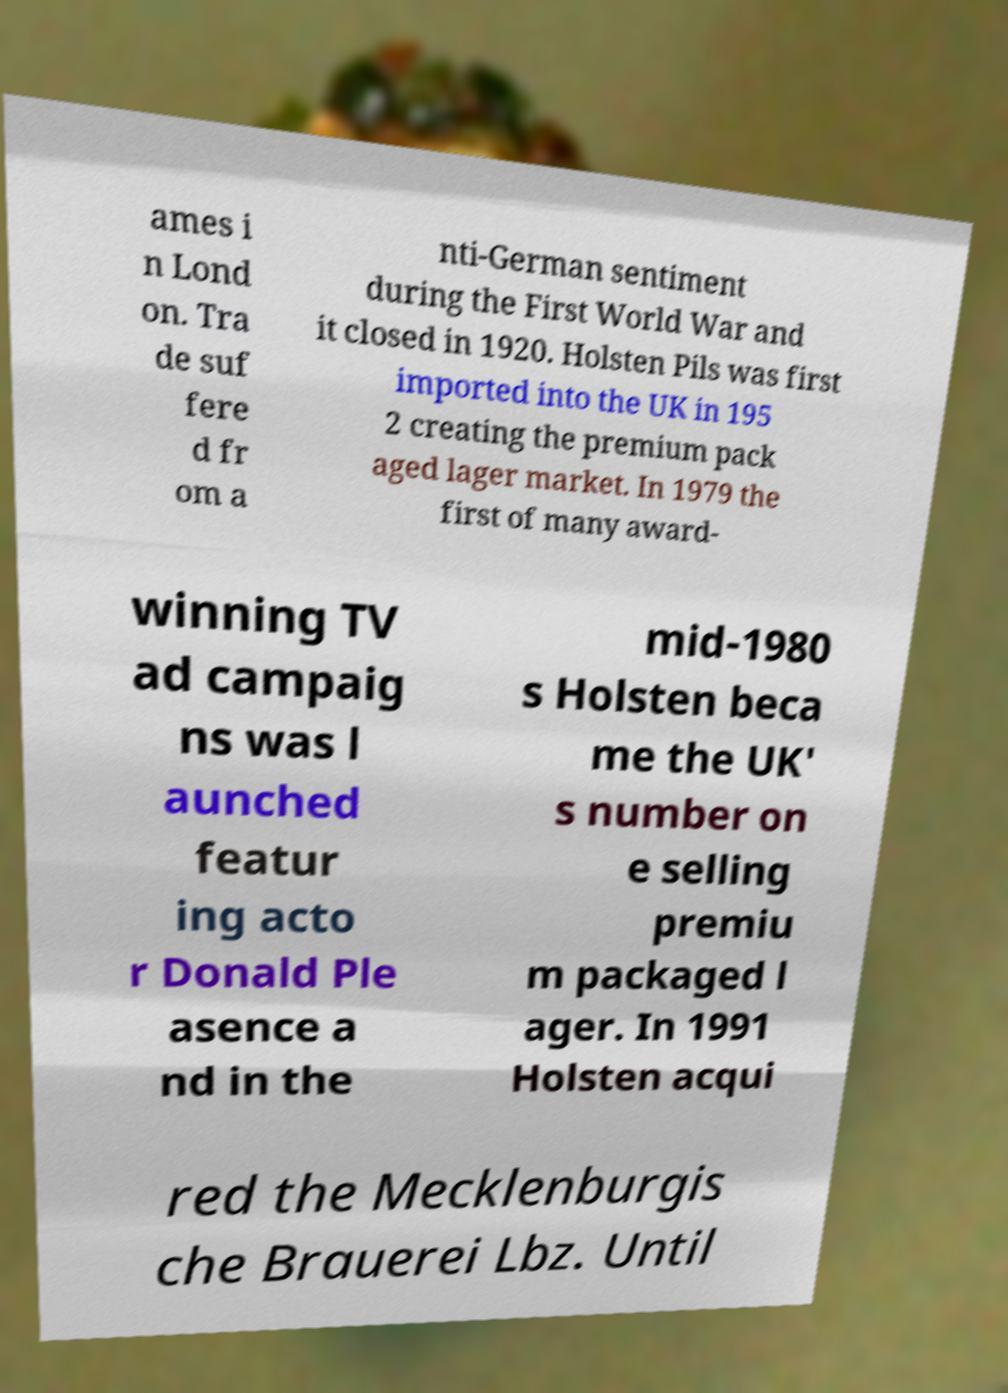Can you accurately transcribe the text from the provided image for me? ames i n Lond on. Tra de suf fere d fr om a nti-German sentiment during the First World War and it closed in 1920. Holsten Pils was first imported into the UK in 195 2 creating the premium pack aged lager market. In 1979 the first of many award- winning TV ad campaig ns was l aunched featur ing acto r Donald Ple asence a nd in the mid-1980 s Holsten beca me the UK' s number on e selling premiu m packaged l ager. In 1991 Holsten acqui red the Mecklenburgis che Brauerei Lbz. Until 